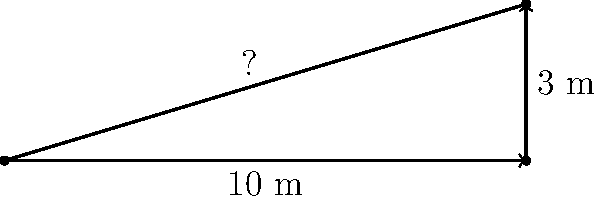You want to ensure proper drainage for your sloped lawn. The lawn has a horizontal length of 10 meters and rises 3 meters in height. What is the angle of the slope in degrees? To find the angle of the slope, we can use trigonometry. Let's approach this step-by-step:

1. We have a right triangle where:
   - The base (adjacent side) is 10 meters
   - The height (opposite side) is 3 meters
   - We need to find the angle

2. In this case, we can use the tangent function. The tangent of an angle is the ratio of the opposite side to the adjacent side.

3. Let θ be the angle we're looking for. Then:

   $$ \tan(\theta) = \frac{\text{opposite}}{\text{adjacent}} = \frac{3}{10} = 0.3 $$

4. To find θ, we need to use the inverse tangent (arctan or tan^(-1)):

   $$ \theta = \tan^{-1}(0.3) $$

5. Using a calculator or mathematical software:

   $$ \theta \approx 16.70° $$

6. Round to two decimal places for precision.

Thus, the angle of the slope is approximately 16.70°.
Answer: 16.70° 